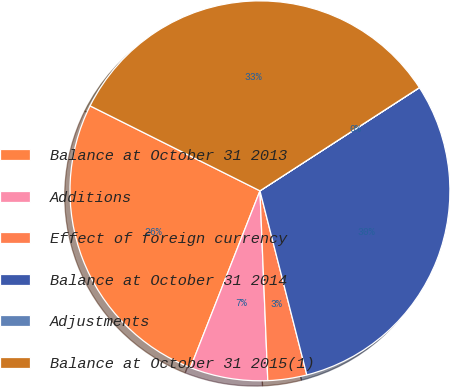<chart> <loc_0><loc_0><loc_500><loc_500><pie_chart><fcel>Balance at October 31 2013<fcel>Additions<fcel>Effect of foreign currency<fcel>Balance at October 31 2014<fcel>Adjustments<fcel>Balance at October 31 2015(1)<nl><fcel>26.42%<fcel>6.62%<fcel>3.31%<fcel>30.17%<fcel>0.01%<fcel>33.47%<nl></chart> 